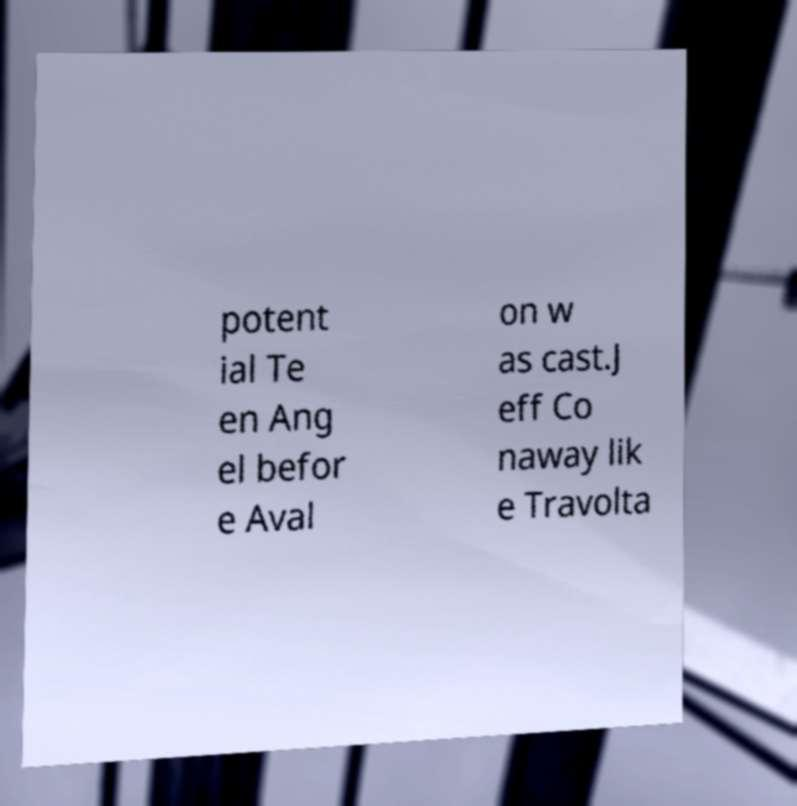Can you accurately transcribe the text from the provided image for me? potent ial Te en Ang el befor e Aval on w as cast.J eff Co naway lik e Travolta 